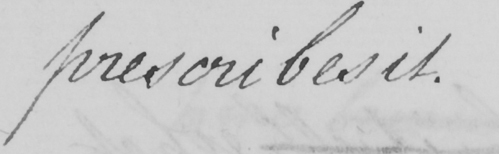Transcribe the text shown in this historical manuscript line. prescribes it. 